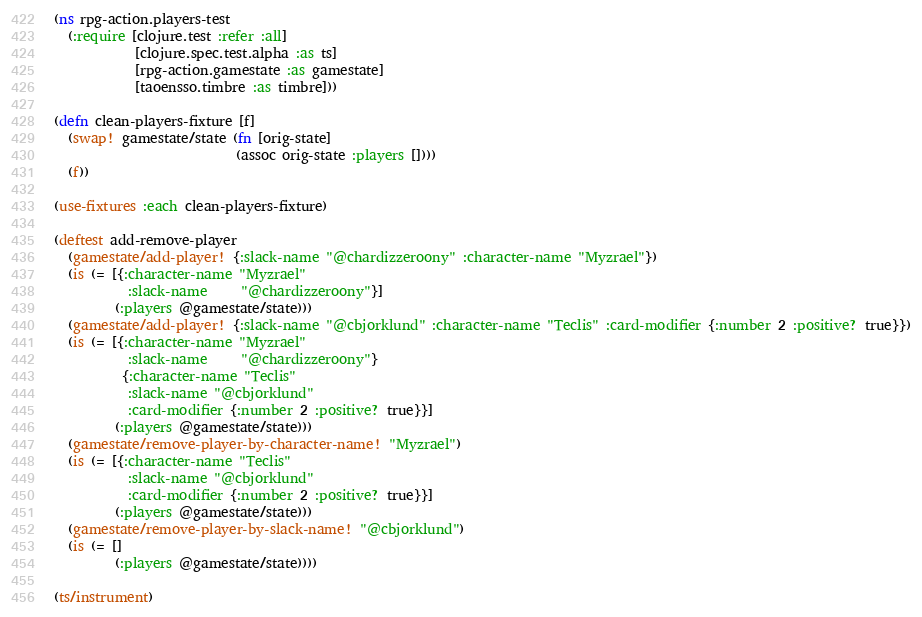<code> <loc_0><loc_0><loc_500><loc_500><_Clojure_>(ns rpg-action.players-test
  (:require [clojure.test :refer :all]
            [clojure.spec.test.alpha :as ts]
            [rpg-action.gamestate :as gamestate]
            [taoensso.timbre :as timbre]))

(defn clean-players-fixture [f]
  (swap! gamestate/state (fn [orig-state]
                           (assoc orig-state :players [])))
  (f))

(use-fixtures :each clean-players-fixture)

(deftest add-remove-player
  (gamestate/add-player! {:slack-name "@chardizzeroony" :character-name "Myzrael"})
  (is (= [{:character-name "Myzrael"
           :slack-name     "@chardizzeroony"}]
         (:players @gamestate/state)))
  (gamestate/add-player! {:slack-name "@cbjorklund" :character-name "Teclis" :card-modifier {:number 2 :positive? true}})
  (is (= [{:character-name "Myzrael"
           :slack-name     "@chardizzeroony"}
          {:character-name "Teclis"
           :slack-name "@cbjorklund"
           :card-modifier {:number 2 :positive? true}}]
         (:players @gamestate/state)))
  (gamestate/remove-player-by-character-name! "Myzrael")
  (is (= [{:character-name "Teclis"
           :slack-name "@cbjorklund"
           :card-modifier {:number 2 :positive? true}}]
         (:players @gamestate/state)))
  (gamestate/remove-player-by-slack-name! "@cbjorklund")
  (is (= []
         (:players @gamestate/state))))

(ts/instrument)</code> 